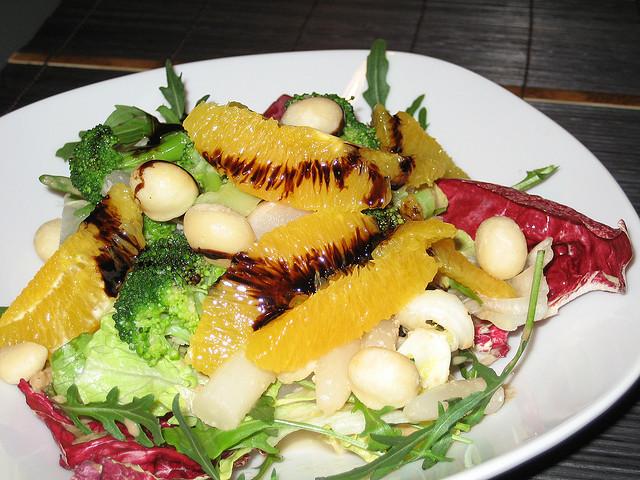Does this meal look healthy?
Short answer required. Yes. What is the Orange things?
Quick response, please. Oranges. Is this a juicy steak dinner?
Quick response, please. No. What does the yellow fruit taste like?
Concise answer only. Sweet. 